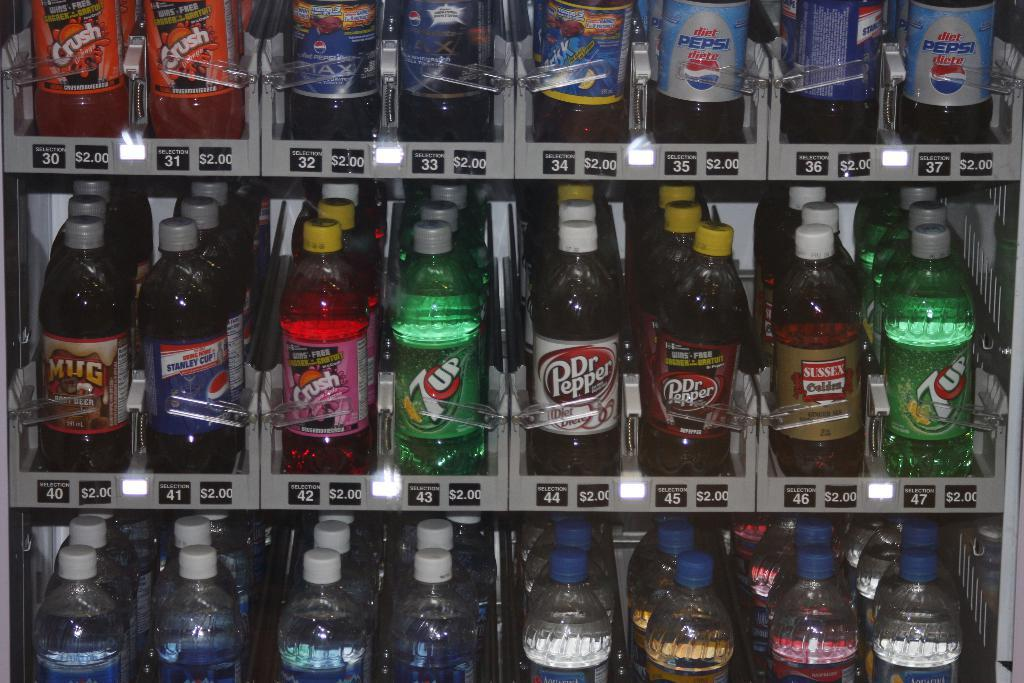<image>
Share a concise interpretation of the image provided. A dispenser machine with different products, 3 rows can be seen and among the products are 7up, Dr. Pepper, Pepsi and other soda products, also water. 